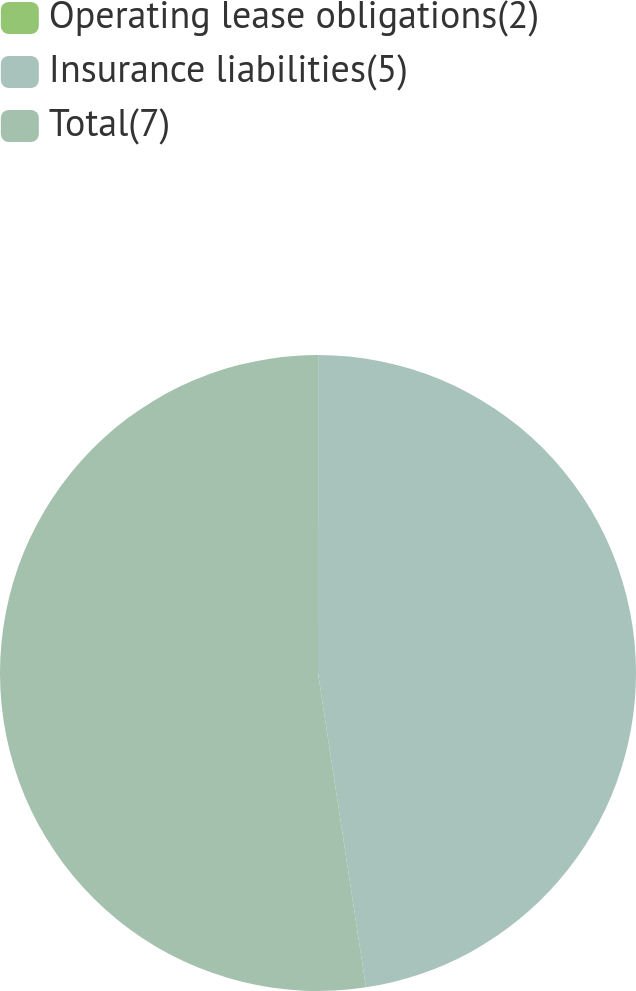Convert chart. <chart><loc_0><loc_0><loc_500><loc_500><pie_chart><fcel>Operating lease obligations(2)<fcel>Insurance liabilities(5)<fcel>Total(7)<nl><fcel>0.01%<fcel>47.58%<fcel>52.41%<nl></chart> 